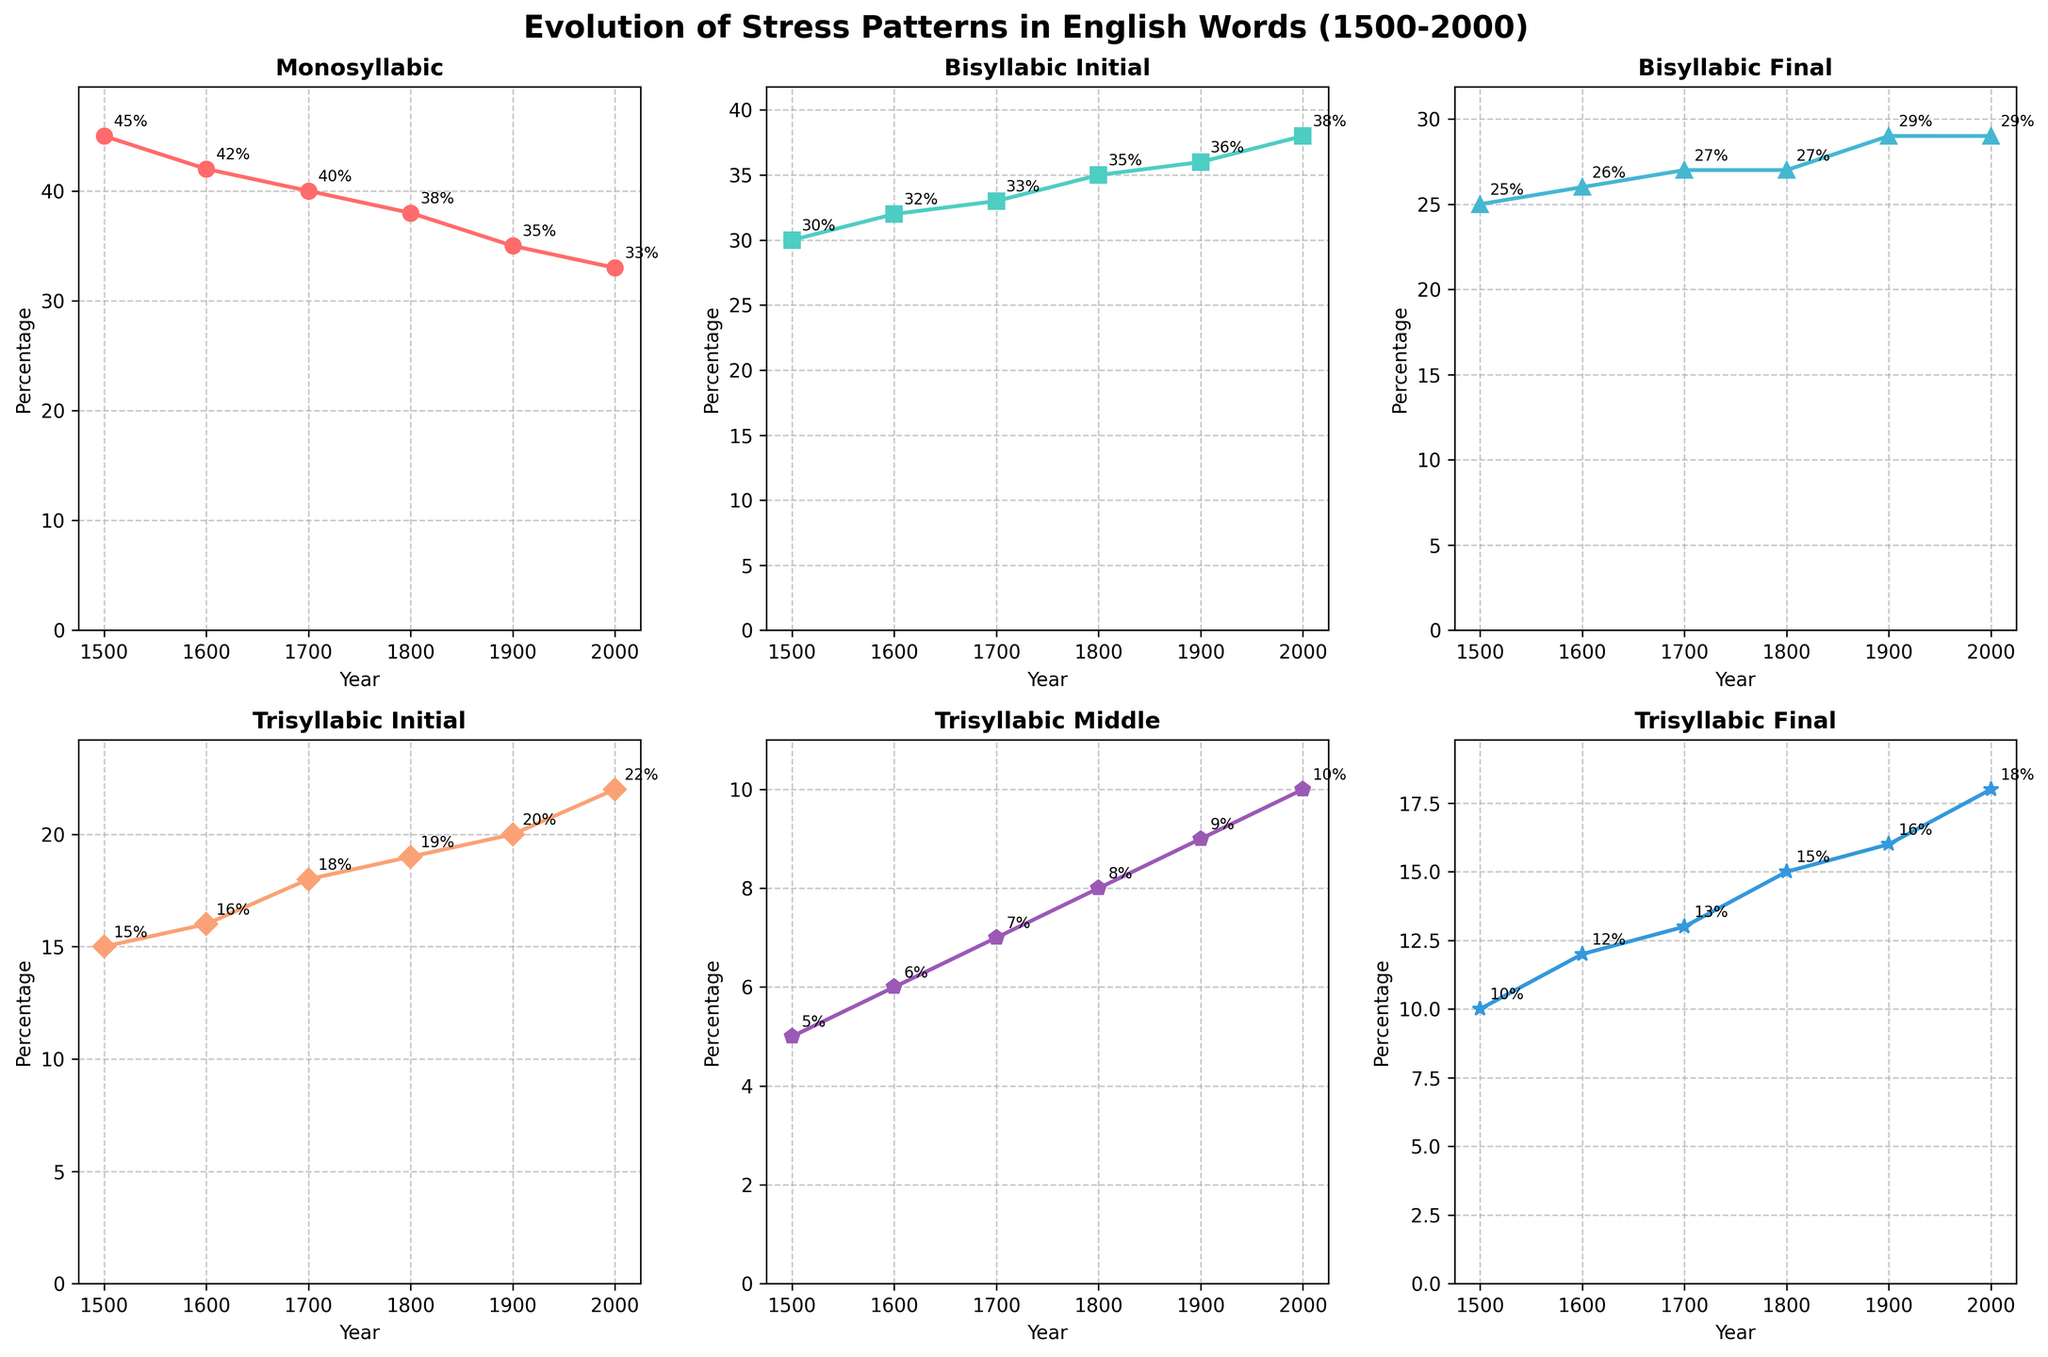What's the title of the figure? The title of the figure is located at the top of the plot in a larger and bold font. It summarizes the main topic of the plot, stating what is being visualized.
Answer: Evolution of Stress Patterns in English Words (1500-2000) How many subplots are there in the figure? The figure contains a 2x3 grid of subplots, which means there are 2 rows and 3 columns of subplots, resulting in a total of 6 subplots.
Answer: 6 What is the percentage of Monosyllabic words in the year 1800? Looking at the subplot for Monosyllabic words, find the data point corresponding to the year 1800. It is labeled and can be read directly from the plot.
Answer: 38% Which type of bisyllabic stress pattern shows an increase from the year 1500 to 2000? Examine the trends for Bisyllabic_Initial and Bisyllabic_Final subplots by comparing their data points from 1500 to 2000. Observe which line has increased over time.
Answer: Bisyllabic_Initial By how much has the percentage of Trisyllabic_Final words changed from 1500 to 2000? Look at the Trisyllabic_Final subplot and find the values for the years 1500 and 2000. Subtract the percentage in 1500 from the percentage in 2000 to find the difference.
Answer: 8% What is the trend in the percentage of Monosyllabic words from 1500 to 2000? Examine the Monosyllabic subplot line from 1500 to 2000. Note if the line is increasing, decreasing, or remaining constant over this period.
Answer: Decreasing Which year marked the highest percentage of Monosyllabic words, and what was the percentage? Scan the Monosyllabic subplot for the highest point on the line. Note the corresponding year and the percentage indicated.
Answer: 1500, 45% Did the percentage of Bisyllabic_Final words ever surpass that of Bisyllabic_Initial words between 1500 and 2000? Compare the subplots for Bisyllabic_Initial and Bisyllabic_Final across the entire time range (1500-2000). Look for any year where the Bisyllabic_Final line is higher than the Bisyllabic_Initial line.
Answer: No Which trisyllabic stress pattern had the lowest percentage in 2000? From the three trisyllabic subplots (Initial, Middle, Final), check the percentages for the year 2000. Identify the subplot with the lowest percentage.
Answer: Trisyllabic_Middle On average, how did the percentage of all types of words change from 1500 to 2000? Calculate the difference for each stress pattern's percentage between 1500 and 2000, sum these differences, and then divide by the number of stress patterns (6) to get the average change.
Answer: -1% 